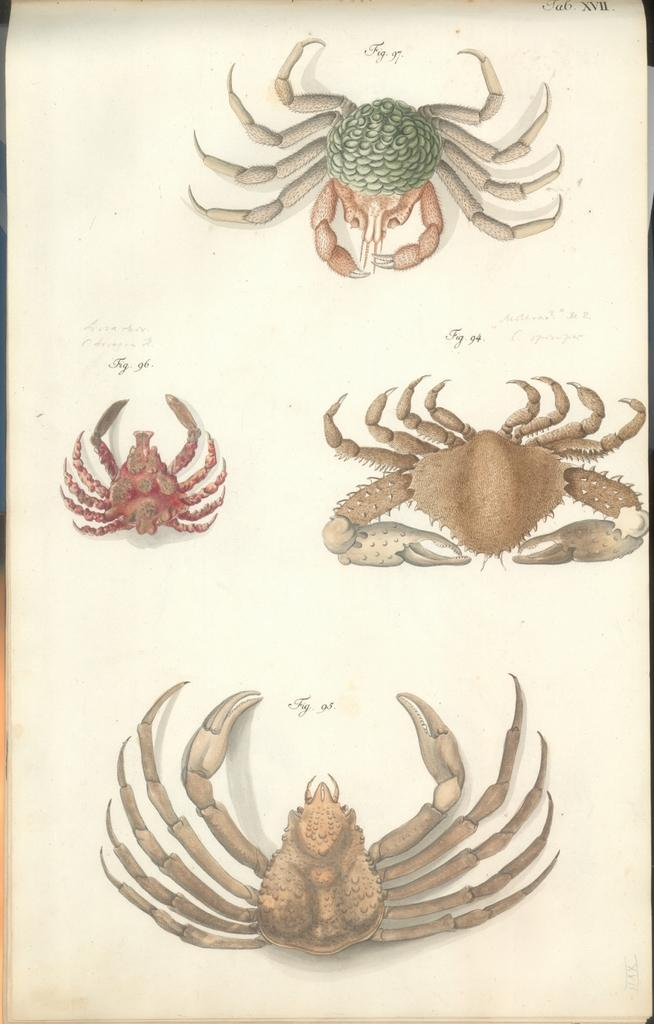What type of animals are present in the image? The image contains different kinds of crabs. Is there any text or writing in the image? Yes, there is writing on the paper. What type of canvas is the judge using to make their decision in the image? There is no judge or canvas present in the image; it features different kinds of crabs and writing on paper. 